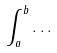Convert formula to latex. <formula><loc_0><loc_0><loc_500><loc_500>\int _ { a } ^ { b } \dots</formula> 